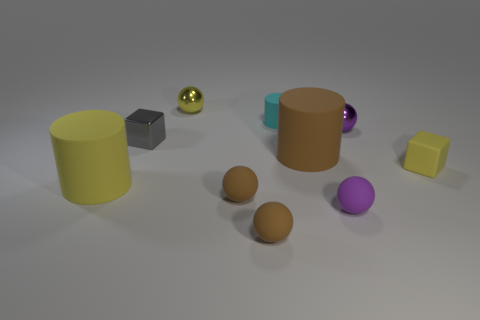Subtract all small purple balls. How many balls are left? 3 Subtract all purple cylinders. How many purple balls are left? 2 Subtract all yellow cylinders. How many cylinders are left? 2 Subtract 1 balls. How many balls are left? 4 Subtract 0 red cylinders. How many objects are left? 10 Subtract all blocks. How many objects are left? 8 Subtract all green cylinders. Subtract all blue balls. How many cylinders are left? 3 Subtract all yellow matte things. Subtract all matte cylinders. How many objects are left? 5 Add 1 rubber balls. How many rubber balls are left? 4 Add 4 brown matte balls. How many brown matte balls exist? 6 